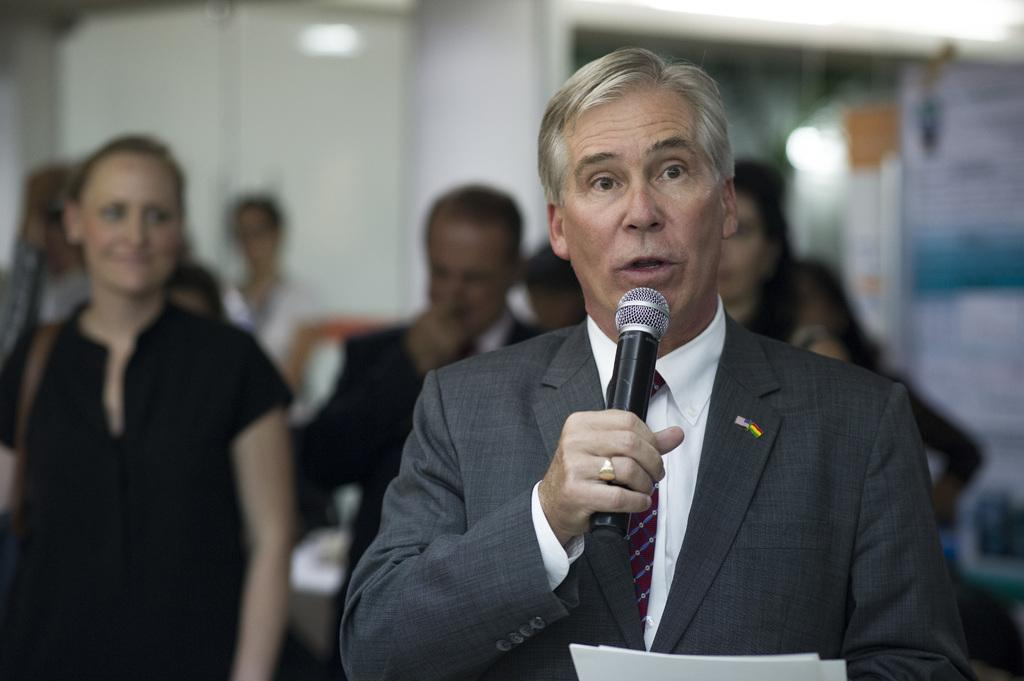What is the man in the image wearing? The man in the image is wearing a suit. What is the man doing with the object in his hand? The man is talking into a microphone. What is the woman in the image wearing? The woman in the image is wearing a black dress. How many people can be seen in the background of the image? There are many people in the background of the image. What can be seen behind the people in the image? There is a wall visible in the background of the image. What sound does the bell make in the image? There is no bell present in the image. What does the man's tongue look like while he is talking into the microphone? The image does not show the man's tongue, so it cannot be described. 